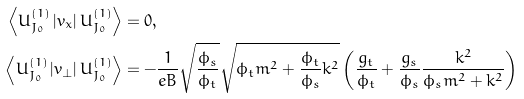Convert formula to latex. <formula><loc_0><loc_0><loc_500><loc_500>\left \langle U ^ { ( 1 ) } _ { J _ { 0 } } \left | v _ { x } \right | U ^ { ( 1 ) } _ { J _ { 0 } } \right \rangle & = 0 , \\ \left \langle U ^ { ( 1 ) } _ { J _ { 0 } } \left | v _ { \perp } \right | U ^ { ( 1 ) } _ { J _ { 0 } } \right \rangle & = - \frac { 1 } { e B } \sqrt { \frac { \phi _ { s } } { \phi _ { t } } } \sqrt { \phi _ { t } m ^ { 2 } + \frac { \phi _ { t } } { \phi _ { s } } k ^ { 2 } } \left ( \frac { g _ { t } } { \phi _ { t } } + \frac { g _ { s } } { \phi _ { s } } \frac { k ^ { 2 } } { \phi _ { s } m ^ { 2 } + k ^ { 2 } } \right )</formula> 